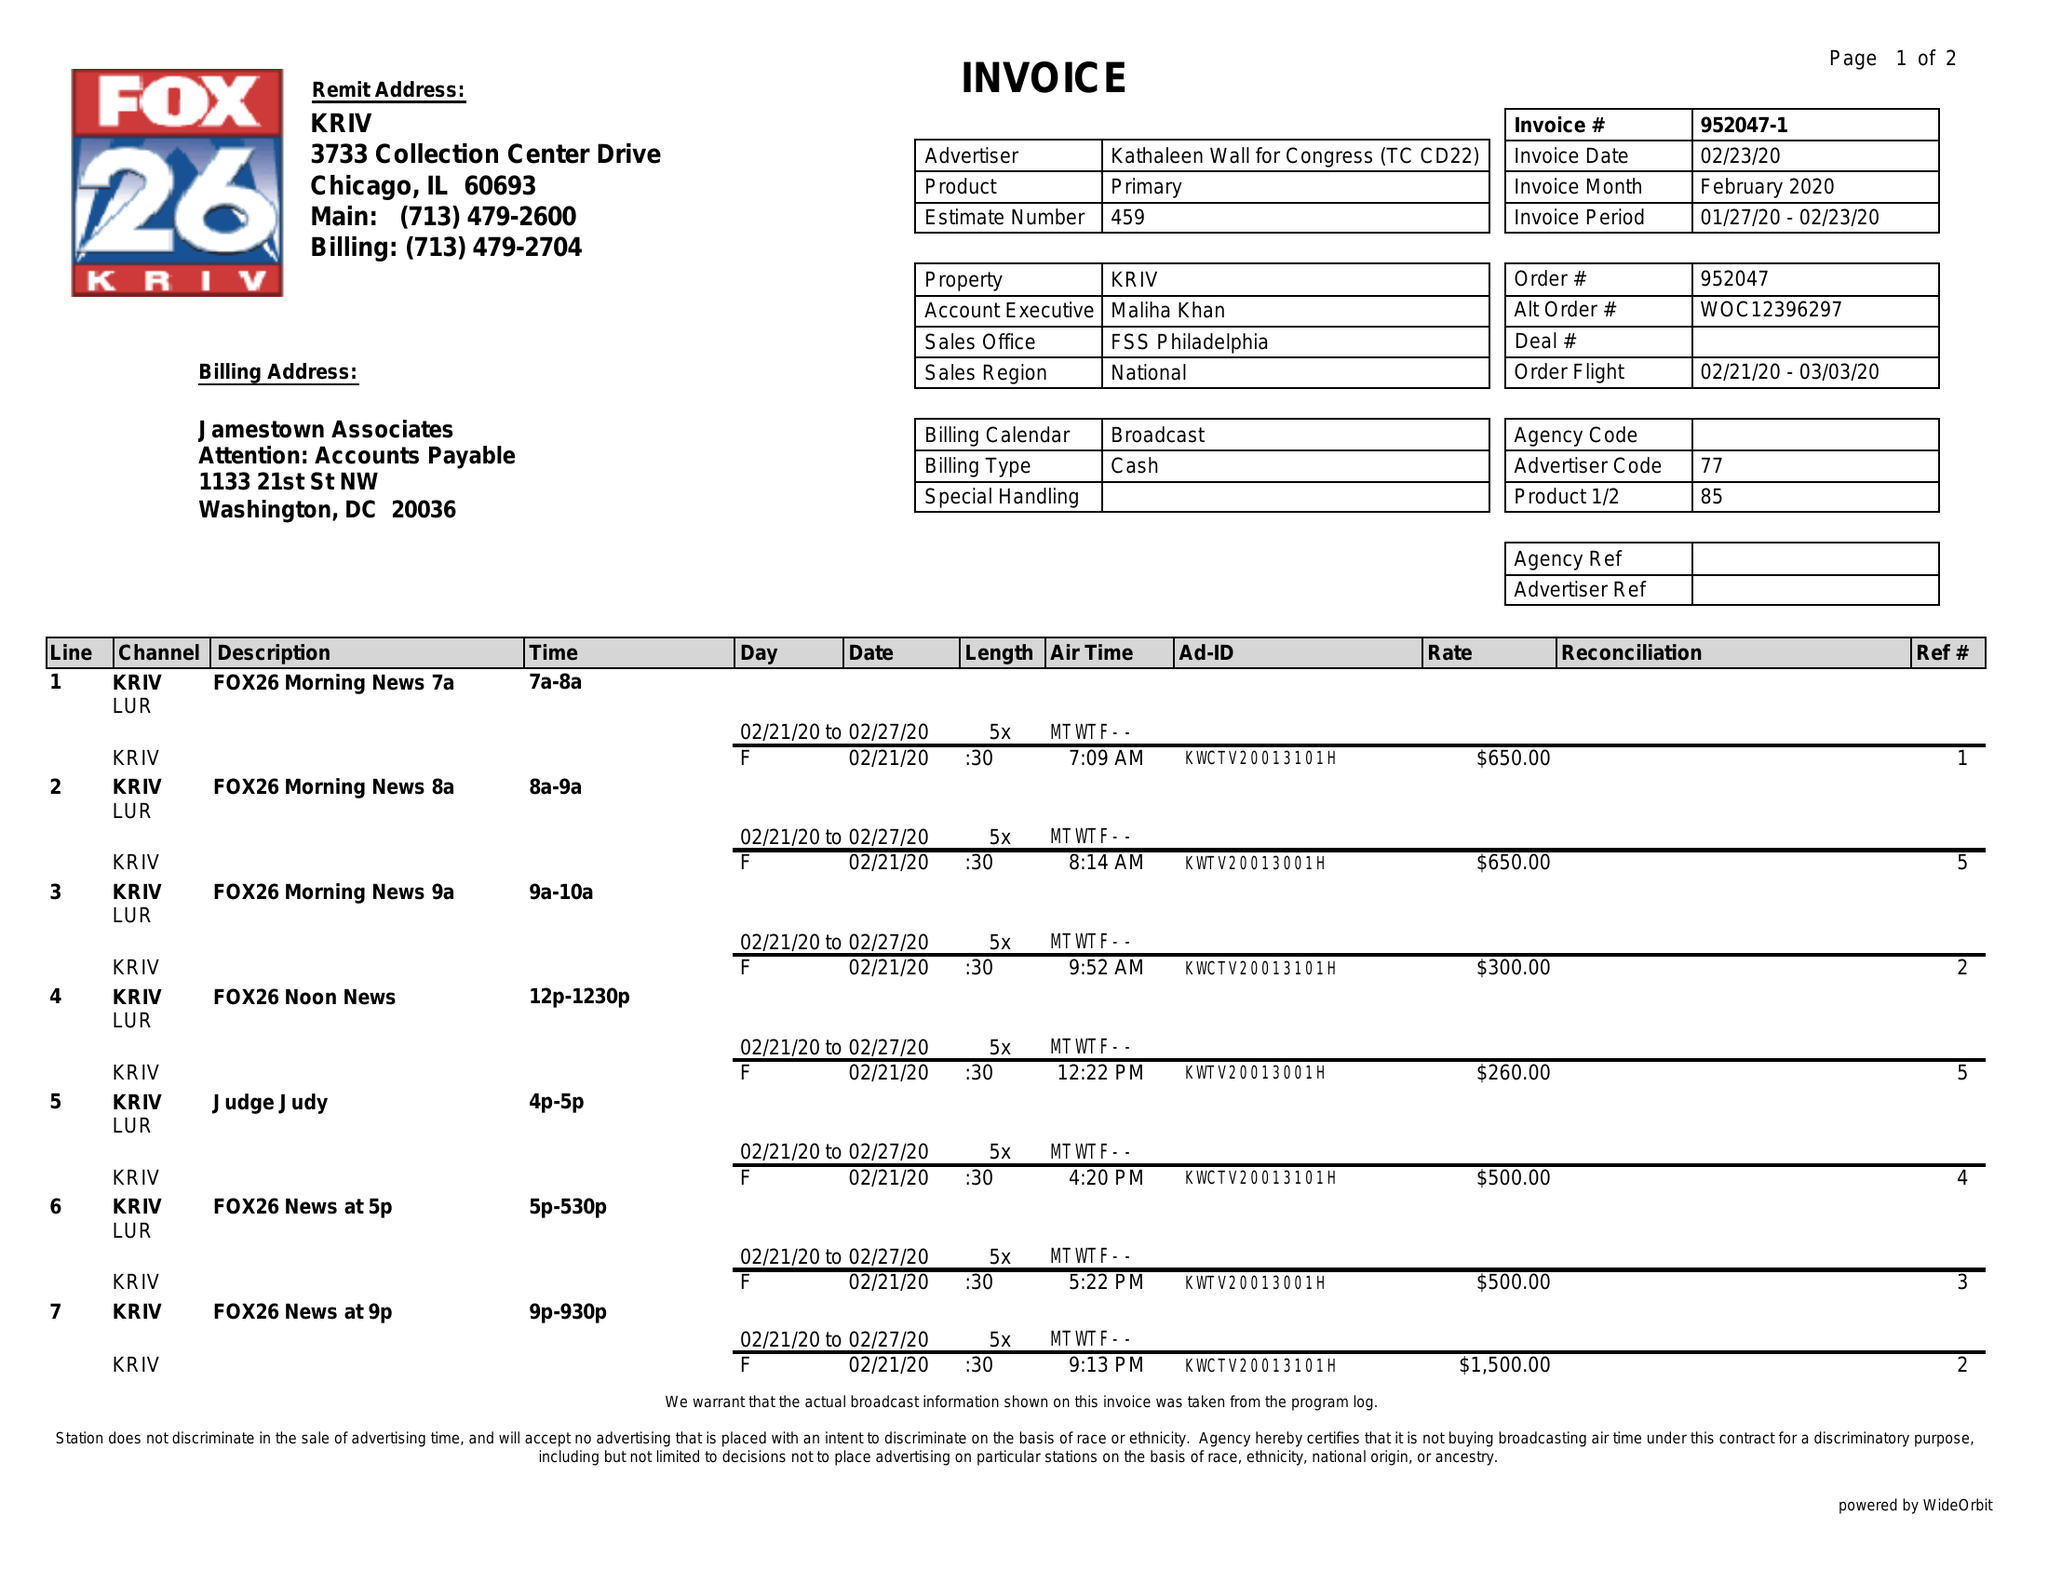What is the value for the flight_from?
Answer the question using a single word or phrase. 02/21/20 